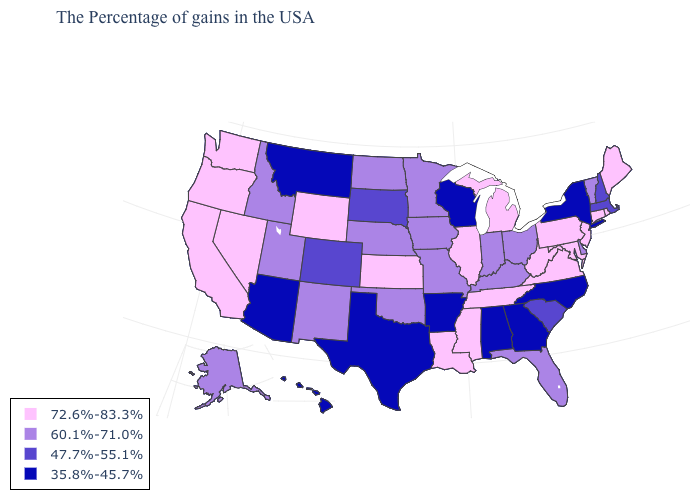Among the states that border North Dakota , which have the highest value?
Give a very brief answer. Minnesota. What is the highest value in the USA?
Keep it brief. 72.6%-83.3%. Name the states that have a value in the range 47.7%-55.1%?
Answer briefly. Massachusetts, New Hampshire, South Carolina, South Dakota, Colorado. Which states have the lowest value in the Northeast?
Write a very short answer. New York. Does the first symbol in the legend represent the smallest category?
Keep it brief. No. What is the lowest value in states that border Pennsylvania?
Give a very brief answer. 35.8%-45.7%. Does Utah have the same value as Minnesota?
Give a very brief answer. Yes. Which states have the lowest value in the South?
Short answer required. North Carolina, Georgia, Alabama, Arkansas, Texas. Among the states that border New Jersey , which have the lowest value?
Give a very brief answer. New York. Does the first symbol in the legend represent the smallest category?
Be succinct. No. What is the value of New Mexico?
Keep it brief. 60.1%-71.0%. What is the highest value in the USA?
Answer briefly. 72.6%-83.3%. What is the lowest value in the USA?
Answer briefly. 35.8%-45.7%. Does Minnesota have the highest value in the MidWest?
Keep it brief. No. 